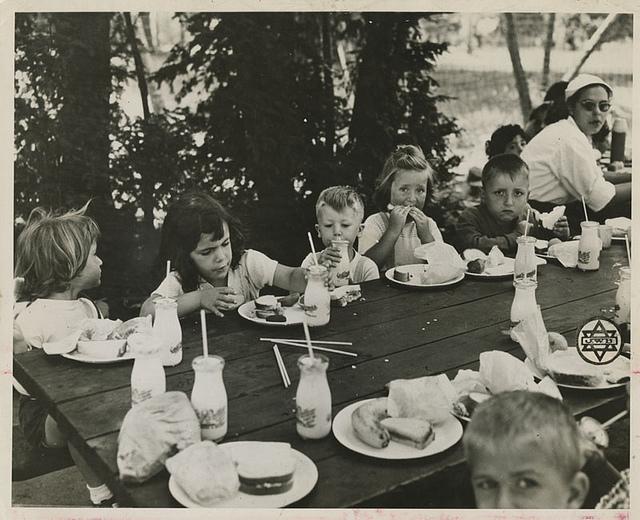How many bottles are in the photo?
Give a very brief answer. 3. How many people are there?
Give a very brief answer. 8. How many dining tables are there?
Give a very brief answer. 1. 